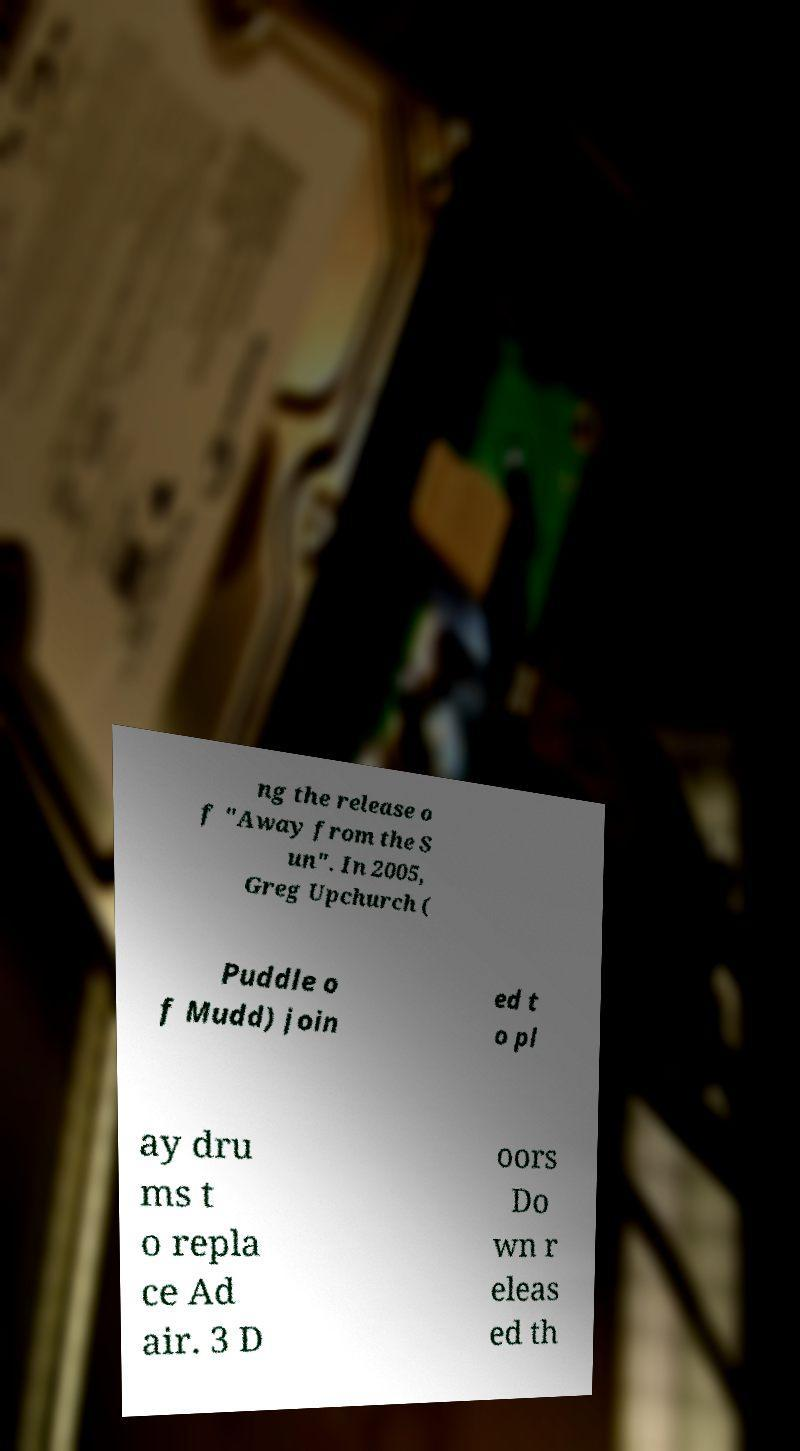Could you assist in decoding the text presented in this image and type it out clearly? ng the release o f "Away from the S un". In 2005, Greg Upchurch ( Puddle o f Mudd) join ed t o pl ay dru ms t o repla ce Ad air. 3 D oors Do wn r eleas ed th 